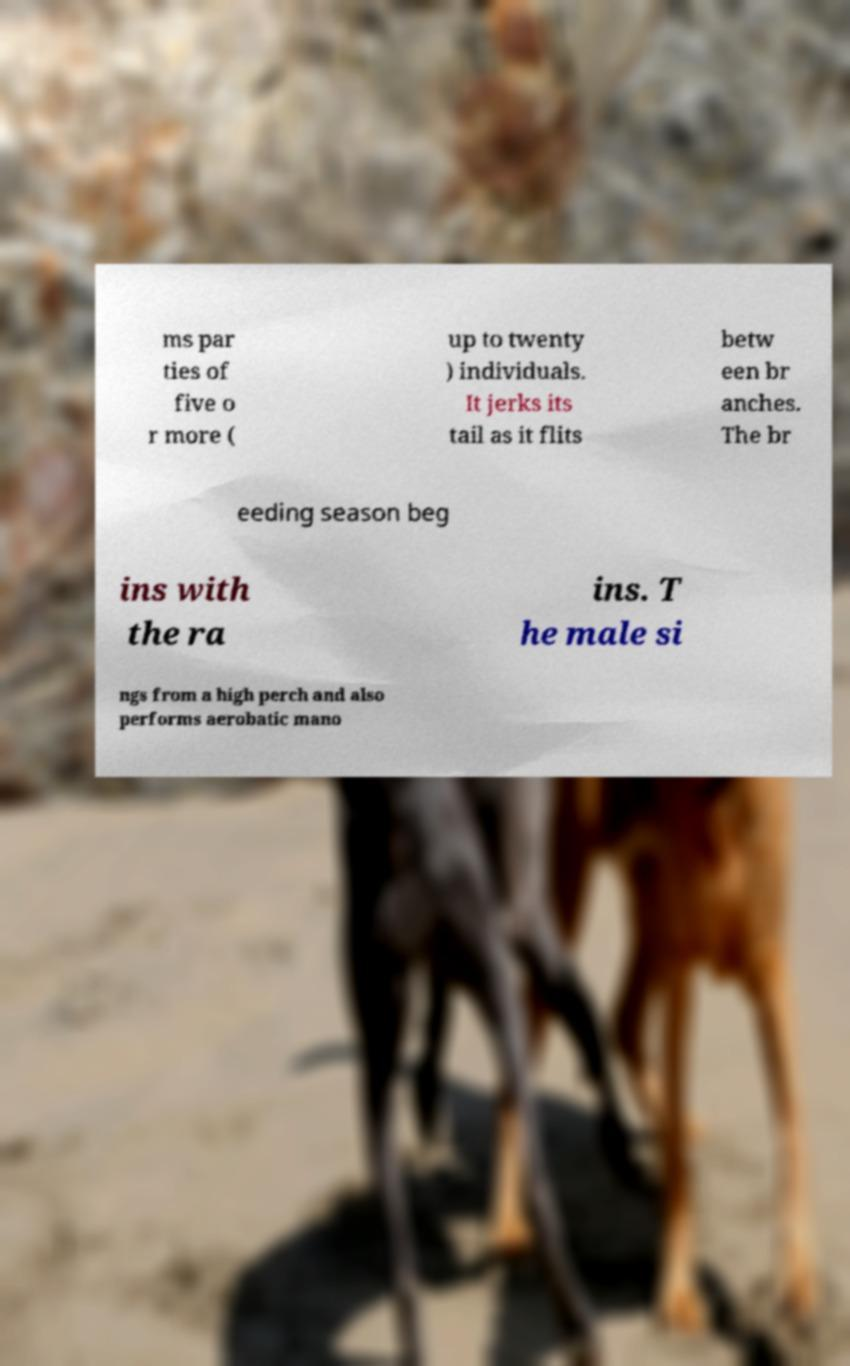I need the written content from this picture converted into text. Can you do that? ms par ties of five o r more ( up to twenty ) individuals. It jerks its tail as it flits betw een br anches. The br eeding season beg ins with the ra ins. T he male si ngs from a high perch and also performs aerobatic mano 